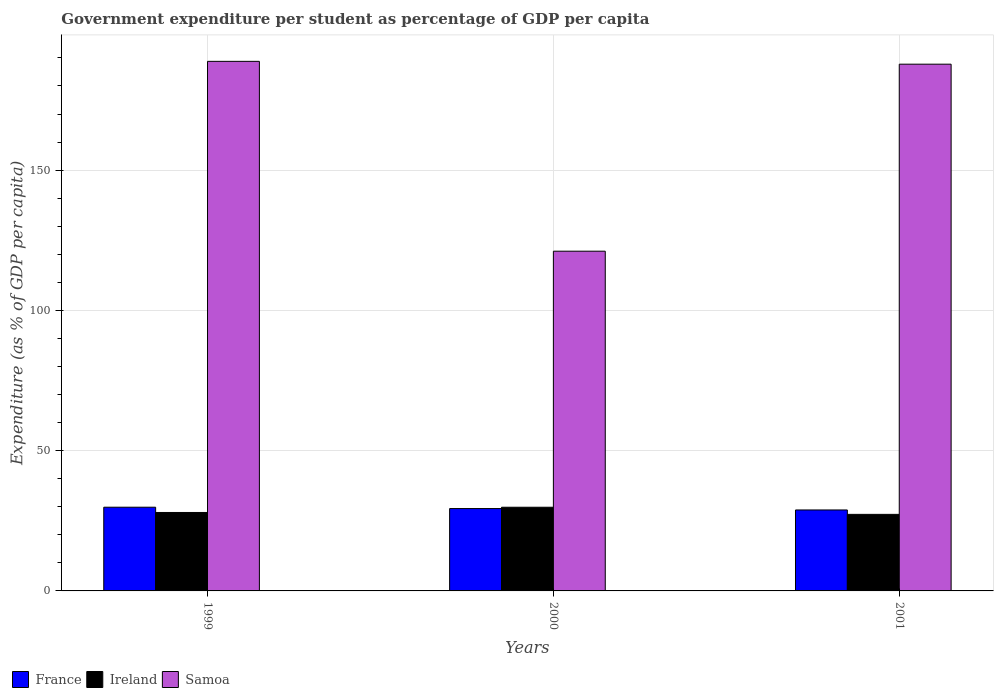How many groups of bars are there?
Offer a very short reply. 3. Are the number of bars per tick equal to the number of legend labels?
Your answer should be very brief. Yes. What is the label of the 1st group of bars from the left?
Ensure brevity in your answer.  1999. In how many cases, is the number of bars for a given year not equal to the number of legend labels?
Make the answer very short. 0. What is the percentage of expenditure per student in France in 2000?
Offer a very short reply. 29.36. Across all years, what is the maximum percentage of expenditure per student in Samoa?
Offer a very short reply. 188.78. Across all years, what is the minimum percentage of expenditure per student in Ireland?
Provide a short and direct response. 27.29. In which year was the percentage of expenditure per student in France maximum?
Your answer should be very brief. 1999. What is the total percentage of expenditure per student in France in the graph?
Make the answer very short. 88.06. What is the difference between the percentage of expenditure per student in Ireland in 1999 and that in 2000?
Your response must be concise. -1.86. What is the difference between the percentage of expenditure per student in France in 2000 and the percentage of expenditure per student in Ireland in 2001?
Your response must be concise. 2.07. What is the average percentage of expenditure per student in Ireland per year?
Offer a very short reply. 28.36. In the year 2000, what is the difference between the percentage of expenditure per student in Samoa and percentage of expenditure per student in France?
Your response must be concise. 91.74. In how many years, is the percentage of expenditure per student in France greater than 160 %?
Make the answer very short. 0. What is the ratio of the percentage of expenditure per student in France in 1999 to that in 2001?
Your answer should be compact. 1.03. Is the percentage of expenditure per student in France in 1999 less than that in 2000?
Keep it short and to the point. No. What is the difference between the highest and the second highest percentage of expenditure per student in Ireland?
Offer a terse response. 1.86. What is the difference between the highest and the lowest percentage of expenditure per student in Samoa?
Offer a terse response. 67.67. In how many years, is the percentage of expenditure per student in Samoa greater than the average percentage of expenditure per student in Samoa taken over all years?
Ensure brevity in your answer.  2. Is the sum of the percentage of expenditure per student in France in 1999 and 2000 greater than the maximum percentage of expenditure per student in Ireland across all years?
Provide a succinct answer. Yes. What does the 3rd bar from the left in 1999 represents?
Offer a very short reply. Samoa. What does the 2nd bar from the right in 2001 represents?
Offer a terse response. Ireland. How many years are there in the graph?
Your answer should be very brief. 3. Does the graph contain any zero values?
Your response must be concise. No. Does the graph contain grids?
Keep it short and to the point. Yes. Where does the legend appear in the graph?
Offer a very short reply. Bottom left. What is the title of the graph?
Provide a short and direct response. Government expenditure per student as percentage of GDP per capita. What is the label or title of the Y-axis?
Keep it short and to the point. Expenditure (as % of GDP per capita). What is the Expenditure (as % of GDP per capita) of France in 1999?
Ensure brevity in your answer.  29.84. What is the Expenditure (as % of GDP per capita) in Ireland in 1999?
Provide a short and direct response. 27.97. What is the Expenditure (as % of GDP per capita) in Samoa in 1999?
Provide a short and direct response. 188.78. What is the Expenditure (as % of GDP per capita) of France in 2000?
Your answer should be compact. 29.36. What is the Expenditure (as % of GDP per capita) of Ireland in 2000?
Ensure brevity in your answer.  29.83. What is the Expenditure (as % of GDP per capita) in Samoa in 2000?
Your answer should be compact. 121.11. What is the Expenditure (as % of GDP per capita) in France in 2001?
Your answer should be compact. 28.86. What is the Expenditure (as % of GDP per capita) in Ireland in 2001?
Your answer should be very brief. 27.29. What is the Expenditure (as % of GDP per capita) in Samoa in 2001?
Your response must be concise. 187.77. Across all years, what is the maximum Expenditure (as % of GDP per capita) in France?
Your response must be concise. 29.84. Across all years, what is the maximum Expenditure (as % of GDP per capita) in Ireland?
Your response must be concise. 29.83. Across all years, what is the maximum Expenditure (as % of GDP per capita) in Samoa?
Offer a very short reply. 188.78. Across all years, what is the minimum Expenditure (as % of GDP per capita) in France?
Keep it short and to the point. 28.86. Across all years, what is the minimum Expenditure (as % of GDP per capita) in Ireland?
Your answer should be very brief. 27.29. Across all years, what is the minimum Expenditure (as % of GDP per capita) of Samoa?
Offer a terse response. 121.11. What is the total Expenditure (as % of GDP per capita) in France in the graph?
Your response must be concise. 88.06. What is the total Expenditure (as % of GDP per capita) in Ireland in the graph?
Give a very brief answer. 85.09. What is the total Expenditure (as % of GDP per capita) in Samoa in the graph?
Make the answer very short. 497.66. What is the difference between the Expenditure (as % of GDP per capita) in France in 1999 and that in 2000?
Give a very brief answer. 0.48. What is the difference between the Expenditure (as % of GDP per capita) of Ireland in 1999 and that in 2000?
Your answer should be very brief. -1.86. What is the difference between the Expenditure (as % of GDP per capita) in Samoa in 1999 and that in 2000?
Give a very brief answer. 67.67. What is the difference between the Expenditure (as % of GDP per capita) of France in 1999 and that in 2001?
Provide a succinct answer. 0.98. What is the difference between the Expenditure (as % of GDP per capita) in Ireland in 1999 and that in 2001?
Your answer should be very brief. 0.67. What is the difference between the Expenditure (as % of GDP per capita) of Samoa in 1999 and that in 2001?
Your response must be concise. 1.01. What is the difference between the Expenditure (as % of GDP per capita) in France in 2000 and that in 2001?
Make the answer very short. 0.5. What is the difference between the Expenditure (as % of GDP per capita) in Ireland in 2000 and that in 2001?
Your answer should be very brief. 2.54. What is the difference between the Expenditure (as % of GDP per capita) in Samoa in 2000 and that in 2001?
Provide a short and direct response. -66.66. What is the difference between the Expenditure (as % of GDP per capita) of France in 1999 and the Expenditure (as % of GDP per capita) of Ireland in 2000?
Offer a very short reply. 0.01. What is the difference between the Expenditure (as % of GDP per capita) in France in 1999 and the Expenditure (as % of GDP per capita) in Samoa in 2000?
Keep it short and to the point. -91.27. What is the difference between the Expenditure (as % of GDP per capita) in Ireland in 1999 and the Expenditure (as % of GDP per capita) in Samoa in 2000?
Your response must be concise. -93.14. What is the difference between the Expenditure (as % of GDP per capita) in France in 1999 and the Expenditure (as % of GDP per capita) in Ireland in 2001?
Your answer should be very brief. 2.55. What is the difference between the Expenditure (as % of GDP per capita) of France in 1999 and the Expenditure (as % of GDP per capita) of Samoa in 2001?
Your answer should be compact. -157.93. What is the difference between the Expenditure (as % of GDP per capita) of Ireland in 1999 and the Expenditure (as % of GDP per capita) of Samoa in 2001?
Provide a succinct answer. -159.8. What is the difference between the Expenditure (as % of GDP per capita) in France in 2000 and the Expenditure (as % of GDP per capita) in Ireland in 2001?
Your answer should be compact. 2.07. What is the difference between the Expenditure (as % of GDP per capita) of France in 2000 and the Expenditure (as % of GDP per capita) of Samoa in 2001?
Your answer should be very brief. -158.41. What is the difference between the Expenditure (as % of GDP per capita) in Ireland in 2000 and the Expenditure (as % of GDP per capita) in Samoa in 2001?
Offer a terse response. -157.94. What is the average Expenditure (as % of GDP per capita) in France per year?
Offer a very short reply. 29.35. What is the average Expenditure (as % of GDP per capita) in Ireland per year?
Provide a succinct answer. 28.36. What is the average Expenditure (as % of GDP per capita) in Samoa per year?
Provide a short and direct response. 165.89. In the year 1999, what is the difference between the Expenditure (as % of GDP per capita) of France and Expenditure (as % of GDP per capita) of Ireland?
Ensure brevity in your answer.  1.87. In the year 1999, what is the difference between the Expenditure (as % of GDP per capita) in France and Expenditure (as % of GDP per capita) in Samoa?
Make the answer very short. -158.94. In the year 1999, what is the difference between the Expenditure (as % of GDP per capita) in Ireland and Expenditure (as % of GDP per capita) in Samoa?
Your answer should be very brief. -160.81. In the year 2000, what is the difference between the Expenditure (as % of GDP per capita) in France and Expenditure (as % of GDP per capita) in Ireland?
Make the answer very short. -0.47. In the year 2000, what is the difference between the Expenditure (as % of GDP per capita) of France and Expenditure (as % of GDP per capita) of Samoa?
Provide a succinct answer. -91.74. In the year 2000, what is the difference between the Expenditure (as % of GDP per capita) of Ireland and Expenditure (as % of GDP per capita) of Samoa?
Your answer should be very brief. -91.28. In the year 2001, what is the difference between the Expenditure (as % of GDP per capita) in France and Expenditure (as % of GDP per capita) in Ireland?
Make the answer very short. 1.57. In the year 2001, what is the difference between the Expenditure (as % of GDP per capita) in France and Expenditure (as % of GDP per capita) in Samoa?
Your response must be concise. -158.91. In the year 2001, what is the difference between the Expenditure (as % of GDP per capita) in Ireland and Expenditure (as % of GDP per capita) in Samoa?
Offer a very short reply. -160.48. What is the ratio of the Expenditure (as % of GDP per capita) of France in 1999 to that in 2000?
Make the answer very short. 1.02. What is the ratio of the Expenditure (as % of GDP per capita) of Ireland in 1999 to that in 2000?
Your answer should be compact. 0.94. What is the ratio of the Expenditure (as % of GDP per capita) in Samoa in 1999 to that in 2000?
Make the answer very short. 1.56. What is the ratio of the Expenditure (as % of GDP per capita) of France in 1999 to that in 2001?
Give a very brief answer. 1.03. What is the ratio of the Expenditure (as % of GDP per capita) of Ireland in 1999 to that in 2001?
Provide a short and direct response. 1.02. What is the ratio of the Expenditure (as % of GDP per capita) in Samoa in 1999 to that in 2001?
Provide a succinct answer. 1.01. What is the ratio of the Expenditure (as % of GDP per capita) in France in 2000 to that in 2001?
Give a very brief answer. 1.02. What is the ratio of the Expenditure (as % of GDP per capita) of Ireland in 2000 to that in 2001?
Your response must be concise. 1.09. What is the ratio of the Expenditure (as % of GDP per capita) in Samoa in 2000 to that in 2001?
Make the answer very short. 0.65. What is the difference between the highest and the second highest Expenditure (as % of GDP per capita) in France?
Your answer should be very brief. 0.48. What is the difference between the highest and the second highest Expenditure (as % of GDP per capita) in Ireland?
Your response must be concise. 1.86. What is the difference between the highest and the second highest Expenditure (as % of GDP per capita) of Samoa?
Your response must be concise. 1.01. What is the difference between the highest and the lowest Expenditure (as % of GDP per capita) in France?
Keep it short and to the point. 0.98. What is the difference between the highest and the lowest Expenditure (as % of GDP per capita) in Ireland?
Your answer should be compact. 2.54. What is the difference between the highest and the lowest Expenditure (as % of GDP per capita) of Samoa?
Offer a very short reply. 67.67. 